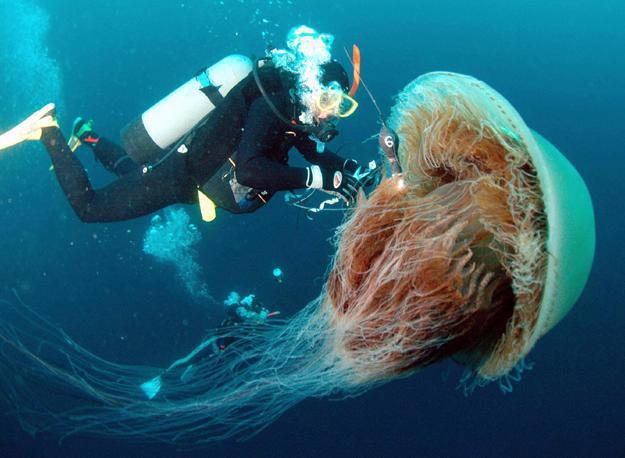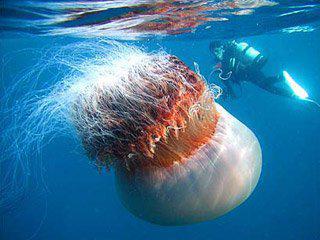The first image is the image on the left, the second image is the image on the right. Assess this claim about the two images: "There is not less than one scuba diver". Correct or not? Answer yes or no. Yes. 